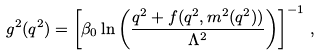<formula> <loc_0><loc_0><loc_500><loc_500>g ^ { 2 } ( q ^ { 2 } ) = \left [ \beta _ { 0 } \ln \left ( \frac { q ^ { 2 } + f ( q ^ { 2 } , m ^ { 2 } ( q ^ { 2 } ) ) } { \Lambda ^ { 2 } } \right ) \right ] ^ { - 1 } \, ,</formula> 